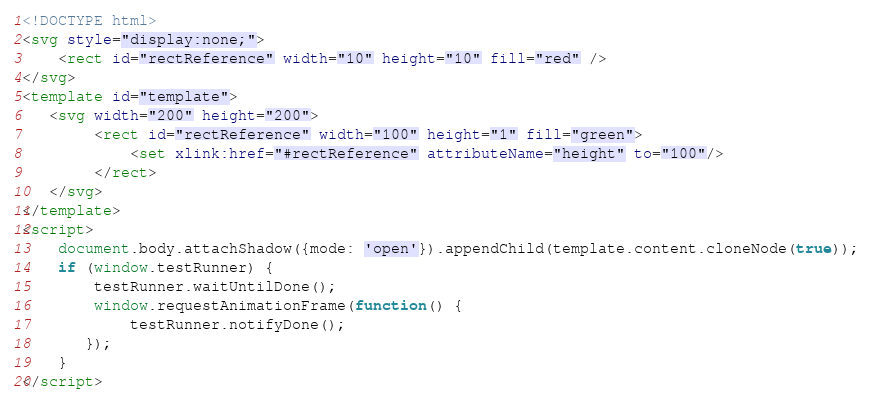Convert code to text. <code><loc_0><loc_0><loc_500><loc_500><_HTML_><!DOCTYPE html>
<svg style="display:none;">
    <rect id="rectReference" width="10" height="10" fill="red" />
</svg>
<template id="template">
   <svg width="200" height="200">
        <rect id="rectReference" width="100" height="1" fill="green">
            <set xlink:href="#rectReference" attributeName="height" to="100"/>
        </rect>
   </svg>
</template>
<script>
    document.body.attachShadow({mode: 'open'}).appendChild(template.content.cloneNode(true));
    if (window.testRunner) {
        testRunner.waitUntilDone();
        window.requestAnimationFrame(function() {
            testRunner.notifyDone();
       });
    }
</script></code> 